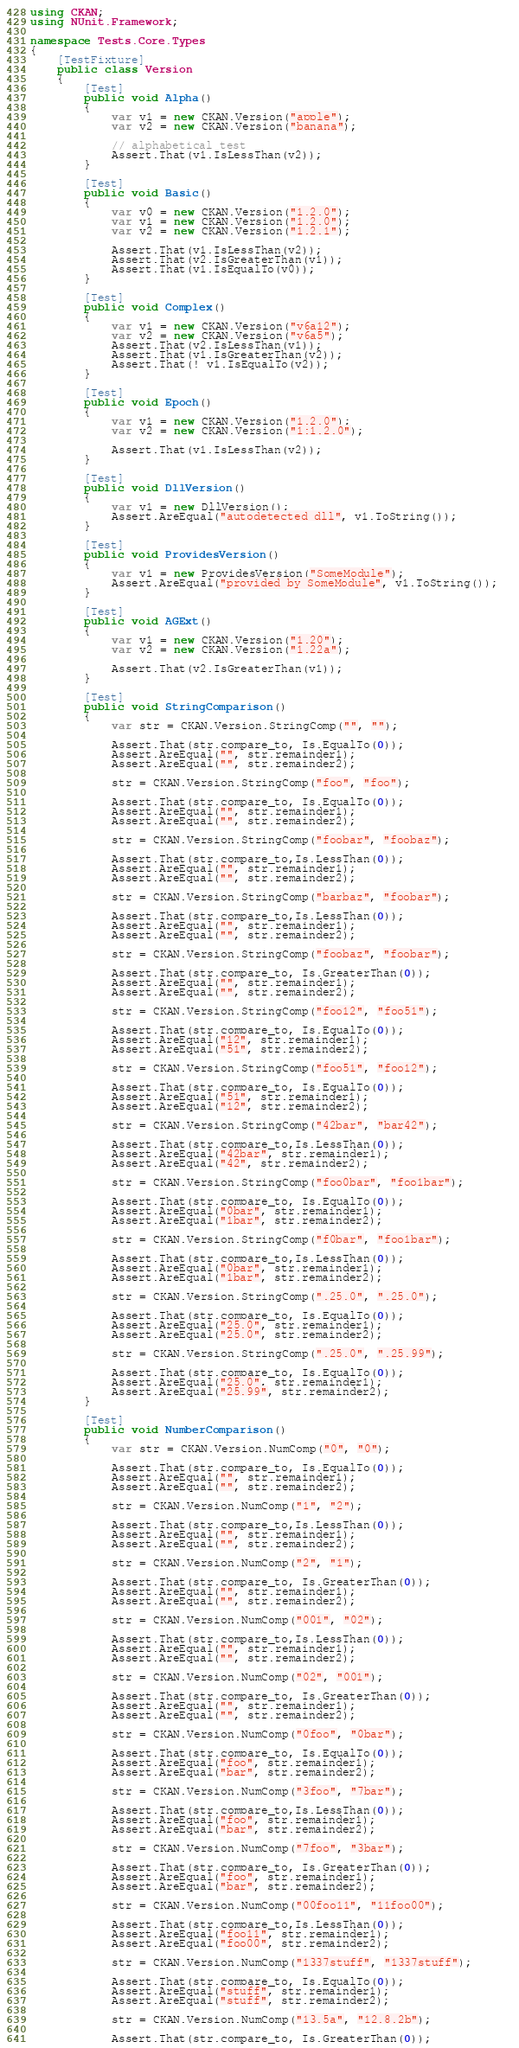<code> <loc_0><loc_0><loc_500><loc_500><_C#_>using CKAN;
using NUnit.Framework;

namespace Tests.Core.Types
{
    [TestFixture]
    public class Version
    {
        [Test]
        public void Alpha()
        {
            var v1 = new CKAN.Version("apple");
            var v2 = new CKAN.Version("banana");

            // alphabetical test
            Assert.That(v1.IsLessThan(v2));
        }

        [Test]
        public void Basic()
        {
            var v0 = new CKAN.Version("1.2.0");
            var v1 = new CKAN.Version("1.2.0");
            var v2 = new CKAN.Version("1.2.1");

            Assert.That(v1.IsLessThan(v2));
            Assert.That(v2.IsGreaterThan(v1));
            Assert.That(v1.IsEqualTo(v0));
        }

        [Test]
        public void Complex()
        {
            var v1 = new CKAN.Version("v6a12");
            var v2 = new CKAN.Version("v6a5");
            Assert.That(v2.IsLessThan(v1));
            Assert.That(v1.IsGreaterThan(v2));
            Assert.That(! v1.IsEqualTo(v2));
        }

        [Test]
        public void Epoch()
        {
            var v1 = new CKAN.Version("1.2.0");
            var v2 = new CKAN.Version("1:1.2.0");

            Assert.That(v1.IsLessThan(v2));
        }

        [Test]
        public void DllVersion()
        {
            var v1 = new DllVersion();
            Assert.AreEqual("autodetected dll", v1.ToString());
        }

        [Test]
        public void ProvidesVersion()
        {
            var v1 = new ProvidesVersion("SomeModule");
            Assert.AreEqual("provided by SomeModule", v1.ToString());
        }

        [Test]
        public void AGExt()
        {
            var v1 = new CKAN.Version("1.20");
            var v2 = new CKAN.Version("1.22a");

            Assert.That(v2.IsGreaterThan(v1));
        }

        [Test]
        public void StringComparison()
        {
            var str = CKAN.Version.StringComp("", "");

            Assert.That(str.compare_to, Is.EqualTo(0));
            Assert.AreEqual("", str.remainder1);
            Assert.AreEqual("", str.remainder2);

            str = CKAN.Version.StringComp("foo", "foo");

            Assert.That(str.compare_to, Is.EqualTo(0));
            Assert.AreEqual("", str.remainder1);
            Assert.AreEqual("", str.remainder2);

            str = CKAN.Version.StringComp("foobar", "foobaz");

            Assert.That(str.compare_to,Is.LessThan(0));
            Assert.AreEqual("", str.remainder1);
            Assert.AreEqual("", str.remainder2);

            str = CKAN.Version.StringComp("barbaz", "foobar");

            Assert.That(str.compare_to,Is.LessThan(0));
            Assert.AreEqual("", str.remainder1);
            Assert.AreEqual("", str.remainder2);

            str = CKAN.Version.StringComp("foobaz", "foobar");

            Assert.That(str.compare_to, Is.GreaterThan(0));            
            Assert.AreEqual("", str.remainder1);
            Assert.AreEqual("", str.remainder2);

            str = CKAN.Version.StringComp("foo12", "foo51");

            Assert.That(str.compare_to, Is.EqualTo(0));
            Assert.AreEqual("12", str.remainder1);
            Assert.AreEqual("51", str.remainder2);

            str = CKAN.Version.StringComp("foo51", "foo12");

            Assert.That(str.compare_to, Is.EqualTo(0));
            Assert.AreEqual("51", str.remainder1);
            Assert.AreEqual("12", str.remainder2);

            str = CKAN.Version.StringComp("42bar", "bar42");

            Assert.That(str.compare_to,Is.LessThan(0));
            Assert.AreEqual("42bar", str.remainder1);
            Assert.AreEqual("42", str.remainder2);

            str = CKAN.Version.StringComp("foo0bar", "foo1bar");

            Assert.That(str.compare_to, Is.EqualTo(0));
            Assert.AreEqual("0bar", str.remainder1);
            Assert.AreEqual("1bar", str.remainder2);

            str = CKAN.Version.StringComp("f0bar", "foo1bar");

            Assert.That(str.compare_to,Is.LessThan(0));
            Assert.AreEqual("0bar", str.remainder1);
            Assert.AreEqual("1bar", str.remainder2);

            str = CKAN.Version.StringComp(".25.0", ".25.0");

            Assert.That(str.compare_to, Is.EqualTo(0));
            Assert.AreEqual("25.0", str.remainder1);
            Assert.AreEqual("25.0", str.remainder2);

            str = CKAN.Version.StringComp(".25.0", ".25.99");

            Assert.That(str.compare_to, Is.EqualTo(0));
            Assert.AreEqual("25.0", str.remainder1);
            Assert.AreEqual("25.99", str.remainder2);
        }

        [Test]
        public void NumberComparison()
        {
            var str = CKAN.Version.NumComp("0", "0");

            Assert.That(str.compare_to, Is.EqualTo(0));
            Assert.AreEqual("", str.remainder1);
            Assert.AreEqual("", str.remainder2);

            str = CKAN.Version.NumComp("1", "2");

            Assert.That(str.compare_to,Is.LessThan(0));
            Assert.AreEqual("", str.remainder1);
            Assert.AreEqual("", str.remainder2);

            str = CKAN.Version.NumComp("2", "1");

            Assert.That(str.compare_to, Is.GreaterThan(0));
            Assert.AreEqual("", str.remainder1);
            Assert.AreEqual("", str.remainder2);

            str = CKAN.Version.NumComp("001", "02");

            Assert.That(str.compare_to,Is.LessThan(0));
            Assert.AreEqual("", str.remainder1);
            Assert.AreEqual("", str.remainder2);

            str = CKAN.Version.NumComp("02", "001");

            Assert.That(str.compare_to, Is.GreaterThan(0));
            Assert.AreEqual("", str.remainder1);
            Assert.AreEqual("", str.remainder2);

            str = CKAN.Version.NumComp("0foo", "0bar");

            Assert.That(str.compare_to, Is.EqualTo(0));
            Assert.AreEqual("foo", str.remainder1);
            Assert.AreEqual("bar", str.remainder2);

            str = CKAN.Version.NumComp("3foo", "7bar");

            Assert.That(str.compare_to,Is.LessThan(0));
            Assert.AreEqual("foo", str.remainder1);
            Assert.AreEqual("bar", str.remainder2);

            str = CKAN.Version.NumComp("7foo", "3bar");

            Assert.That(str.compare_to, Is.GreaterThan(0));
            Assert.AreEqual("foo", str.remainder1);
            Assert.AreEqual("bar", str.remainder2);

            str = CKAN.Version.NumComp("00foo11", "11foo00");

            Assert.That(str.compare_to,Is.LessThan(0));
            Assert.AreEqual("foo11", str.remainder1);
            Assert.AreEqual("foo00", str.remainder2);

            str = CKAN.Version.NumComp("1337stuff", "1337stuff");

            Assert.That(str.compare_to, Is.EqualTo(0));
            Assert.AreEqual("stuff", str.remainder1);
            Assert.AreEqual("stuff", str.remainder2);

            str = CKAN.Version.NumComp("13.5a", "12.8.2b");

            Assert.That(str.compare_to, Is.GreaterThan(0));</code> 